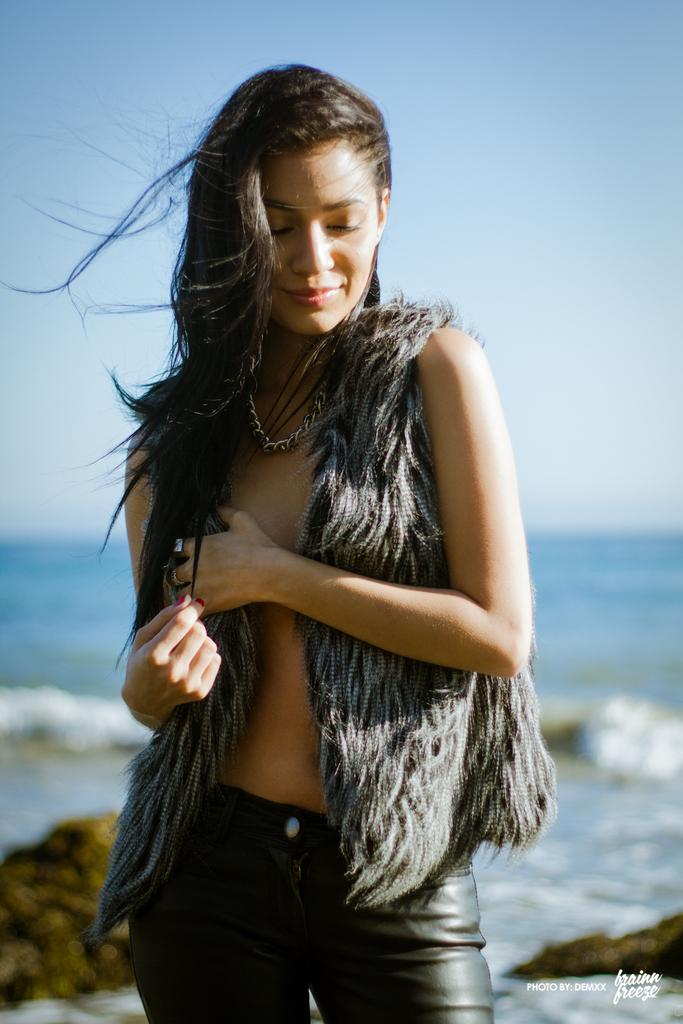Who or what is present in the image? There is a person in the image. What is located behind the person? There are rocks behind the person. What can be seen in the distance in the image? There is water visible in the background of the image. What else is visible in the background of the image? The sky is visible in the background of the image. What type of necklace is the person wearing in the image? There is no necklace visible in the image; the person is not wearing any jewelry. 